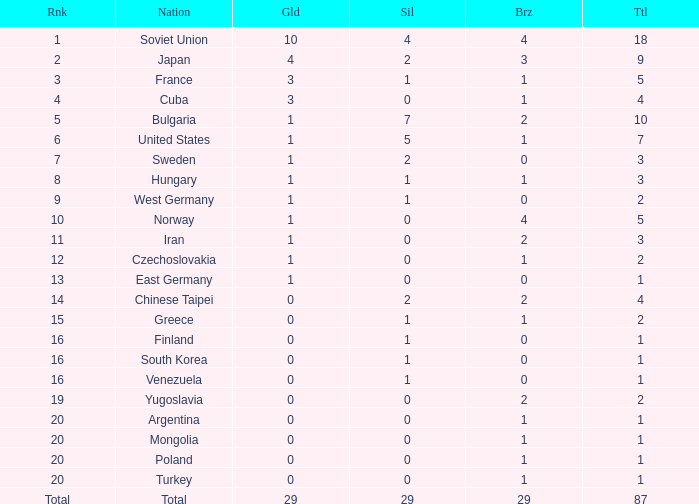What is the average number of bronze medals for total of all nations? 29.0. 